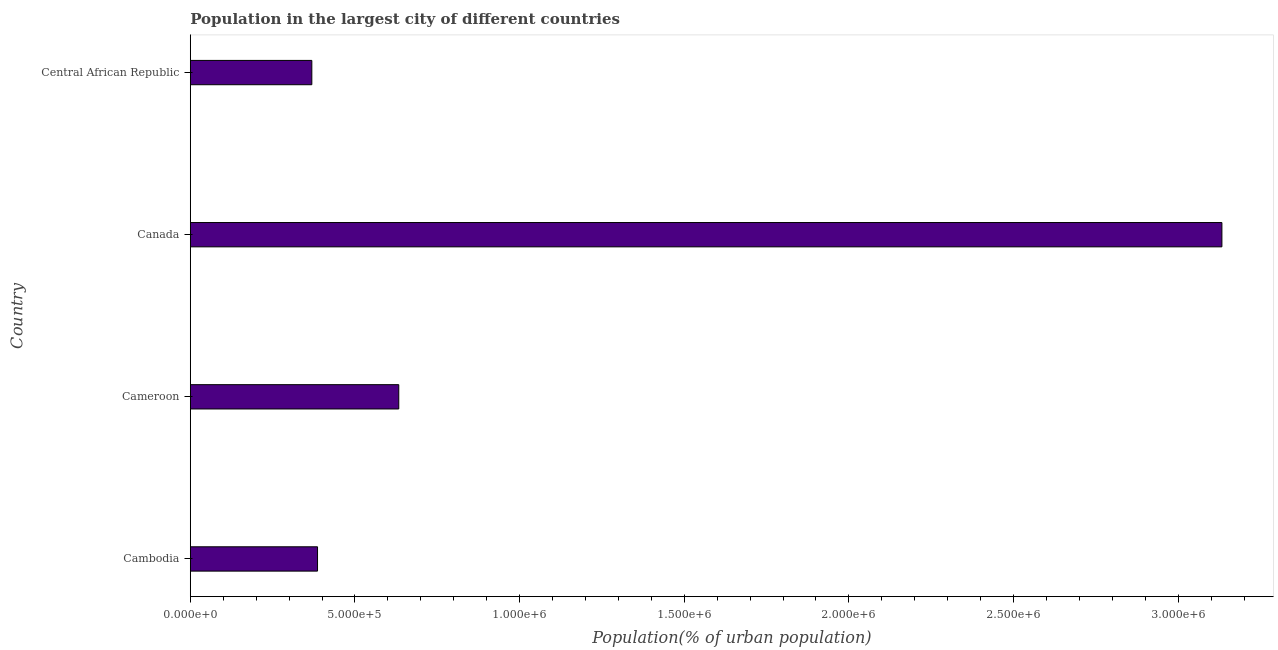Does the graph contain any zero values?
Offer a terse response. No. What is the title of the graph?
Make the answer very short. Population in the largest city of different countries. What is the label or title of the X-axis?
Keep it short and to the point. Population(% of urban population). What is the population in largest city in Cameroon?
Make the answer very short. 6.33e+05. Across all countries, what is the maximum population in largest city?
Provide a succinct answer. 3.13e+06. Across all countries, what is the minimum population in largest city?
Ensure brevity in your answer.  3.69e+05. In which country was the population in largest city maximum?
Provide a succinct answer. Canada. In which country was the population in largest city minimum?
Give a very brief answer. Central African Republic. What is the sum of the population in largest city?
Ensure brevity in your answer.  4.52e+06. What is the difference between the population in largest city in Cambodia and Central African Republic?
Give a very brief answer. 1.73e+04. What is the average population in largest city per country?
Give a very brief answer. 1.13e+06. What is the median population in largest city?
Your response must be concise. 5.10e+05. What is the ratio of the population in largest city in Cameroon to that in Central African Republic?
Keep it short and to the point. 1.72. Is the difference between the population in largest city in Canada and Central African Republic greater than the difference between any two countries?
Offer a terse response. Yes. What is the difference between the highest and the second highest population in largest city?
Offer a terse response. 2.50e+06. What is the difference between the highest and the lowest population in largest city?
Offer a terse response. 2.76e+06. In how many countries, is the population in largest city greater than the average population in largest city taken over all countries?
Provide a succinct answer. 1. How many countries are there in the graph?
Ensure brevity in your answer.  4. What is the difference between two consecutive major ticks on the X-axis?
Ensure brevity in your answer.  5.00e+05. Are the values on the major ticks of X-axis written in scientific E-notation?
Ensure brevity in your answer.  Yes. What is the Population(% of urban population) in Cambodia?
Give a very brief answer. 3.86e+05. What is the Population(% of urban population) of Cameroon?
Provide a short and direct response. 6.33e+05. What is the Population(% of urban population) in Canada?
Your response must be concise. 3.13e+06. What is the Population(% of urban population) of Central African Republic?
Keep it short and to the point. 3.69e+05. What is the difference between the Population(% of urban population) in Cambodia and Cameroon?
Keep it short and to the point. -2.47e+05. What is the difference between the Population(% of urban population) in Cambodia and Canada?
Provide a short and direct response. -2.75e+06. What is the difference between the Population(% of urban population) in Cambodia and Central African Republic?
Ensure brevity in your answer.  1.73e+04. What is the difference between the Population(% of urban population) in Cameroon and Canada?
Your answer should be compact. -2.50e+06. What is the difference between the Population(% of urban population) in Cameroon and Central African Republic?
Keep it short and to the point. 2.64e+05. What is the difference between the Population(% of urban population) in Canada and Central African Republic?
Provide a succinct answer. 2.76e+06. What is the ratio of the Population(% of urban population) in Cambodia to that in Cameroon?
Offer a terse response. 0.61. What is the ratio of the Population(% of urban population) in Cambodia to that in Canada?
Your response must be concise. 0.12. What is the ratio of the Population(% of urban population) in Cambodia to that in Central African Republic?
Your answer should be very brief. 1.05. What is the ratio of the Population(% of urban population) in Cameroon to that in Canada?
Keep it short and to the point. 0.2. What is the ratio of the Population(% of urban population) in Cameroon to that in Central African Republic?
Make the answer very short. 1.72. What is the ratio of the Population(% of urban population) in Canada to that in Central African Republic?
Make the answer very short. 8.49. 